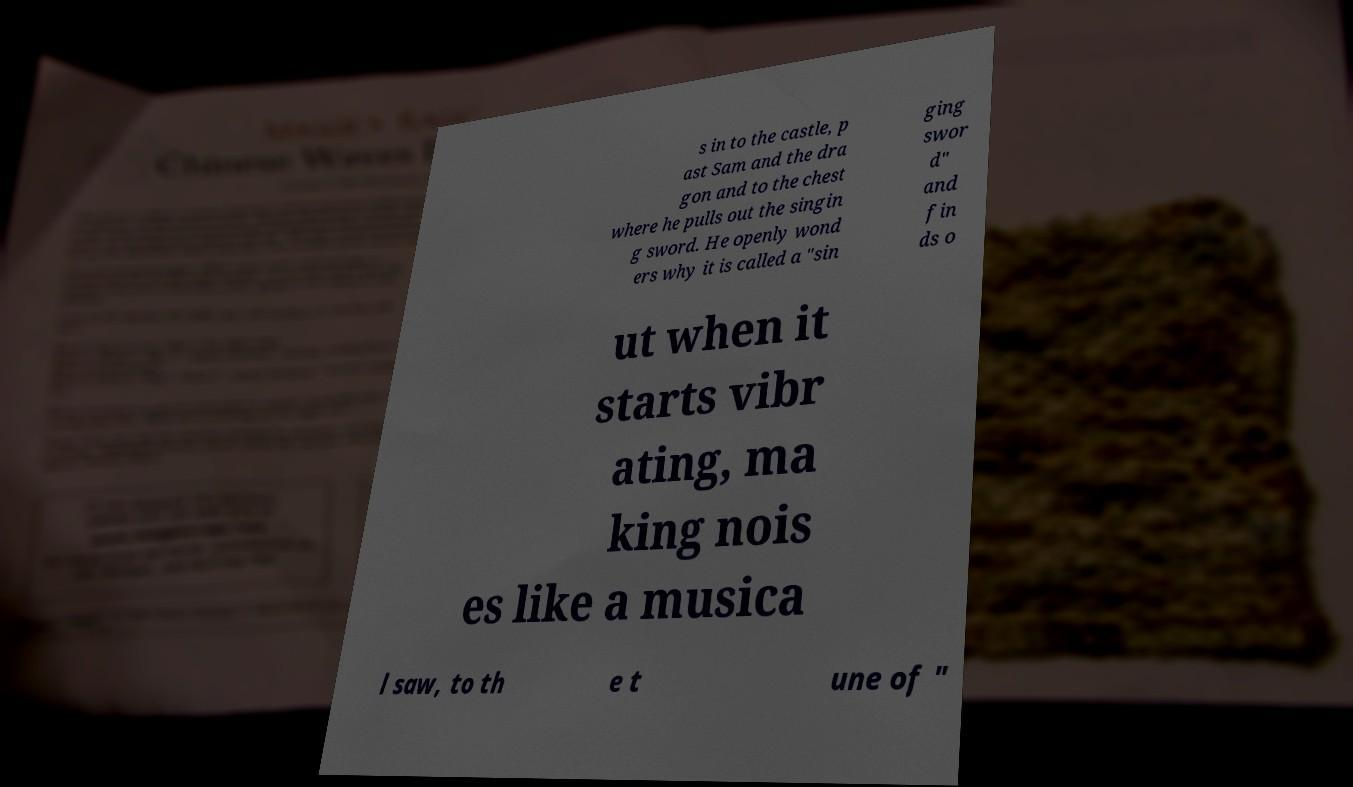There's text embedded in this image that I need extracted. Can you transcribe it verbatim? s in to the castle, p ast Sam and the dra gon and to the chest where he pulls out the singin g sword. He openly wond ers why it is called a "sin ging swor d" and fin ds o ut when it starts vibr ating, ma king nois es like a musica l saw, to th e t une of " 